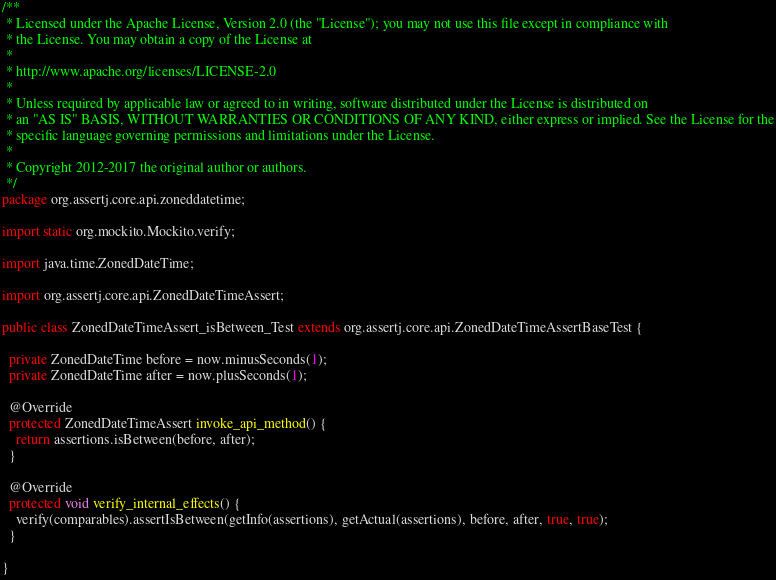Convert code to text. <code><loc_0><loc_0><loc_500><loc_500><_Java_>/**
 * Licensed under the Apache License, Version 2.0 (the "License"); you may not use this file except in compliance with
 * the License. You may obtain a copy of the License at
 *
 * http://www.apache.org/licenses/LICENSE-2.0
 *
 * Unless required by applicable law or agreed to in writing, software distributed under the License is distributed on
 * an "AS IS" BASIS, WITHOUT WARRANTIES OR CONDITIONS OF ANY KIND, either express or implied. See the License for the
 * specific language governing permissions and limitations under the License.
 *
 * Copyright 2012-2017 the original author or authors.
 */
package org.assertj.core.api.zoneddatetime;

import static org.mockito.Mockito.verify;

import java.time.ZonedDateTime;

import org.assertj.core.api.ZonedDateTimeAssert;

public class ZonedDateTimeAssert_isBetween_Test extends org.assertj.core.api.ZonedDateTimeAssertBaseTest {

  private ZonedDateTime before = now.minusSeconds(1);
  private ZonedDateTime after = now.plusSeconds(1);

  @Override
  protected ZonedDateTimeAssert invoke_api_method() {
    return assertions.isBetween(before, after);
  }

  @Override
  protected void verify_internal_effects() {
    verify(comparables).assertIsBetween(getInfo(assertions), getActual(assertions), before, after, true, true);
  }

}
</code> 